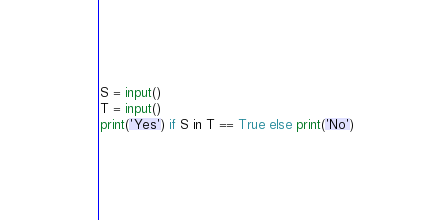Convert code to text. <code><loc_0><loc_0><loc_500><loc_500><_Python_>S = input()
T = input()
print('Yes') if S in T == True else print('No')
</code> 